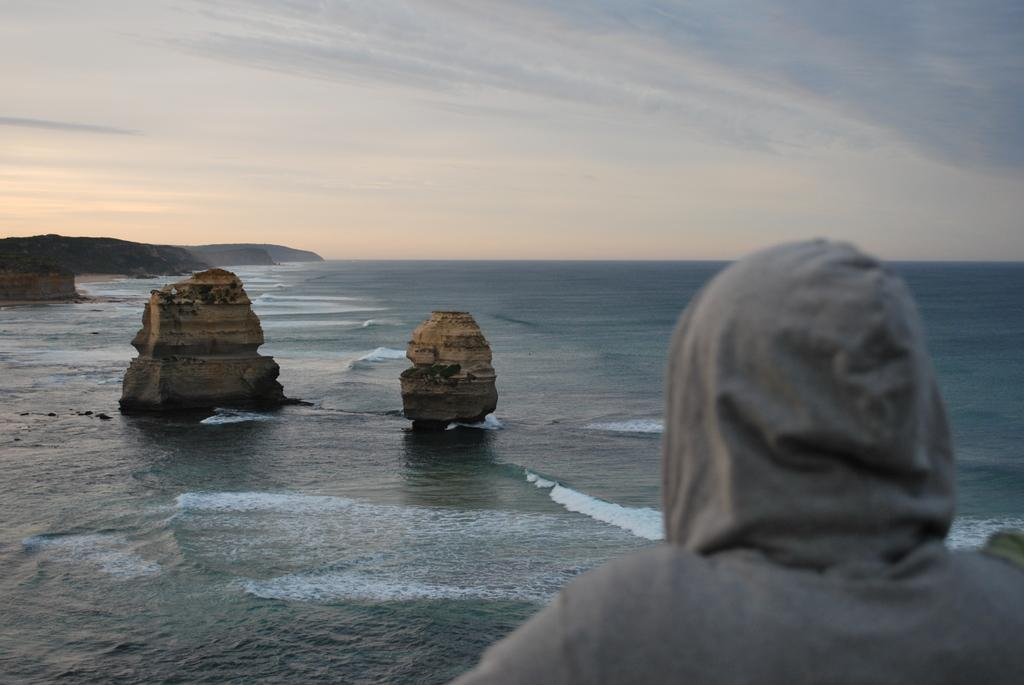Who is present in the image? There is a man in the image. What can be seen in the distance behind the man? There is a sea in the background of the image. What type of natural elements are present in the background? There are stones in the background of the image. How would you describe the weather based on the sky in the image? The sky is cloudy in the background of the image. How many apples are on the man's head in the image? There are no apples present in the image. What type of thrill can be experienced by the man in the image? The image does not depict any specific activity or thrill that the man might be experiencing. 